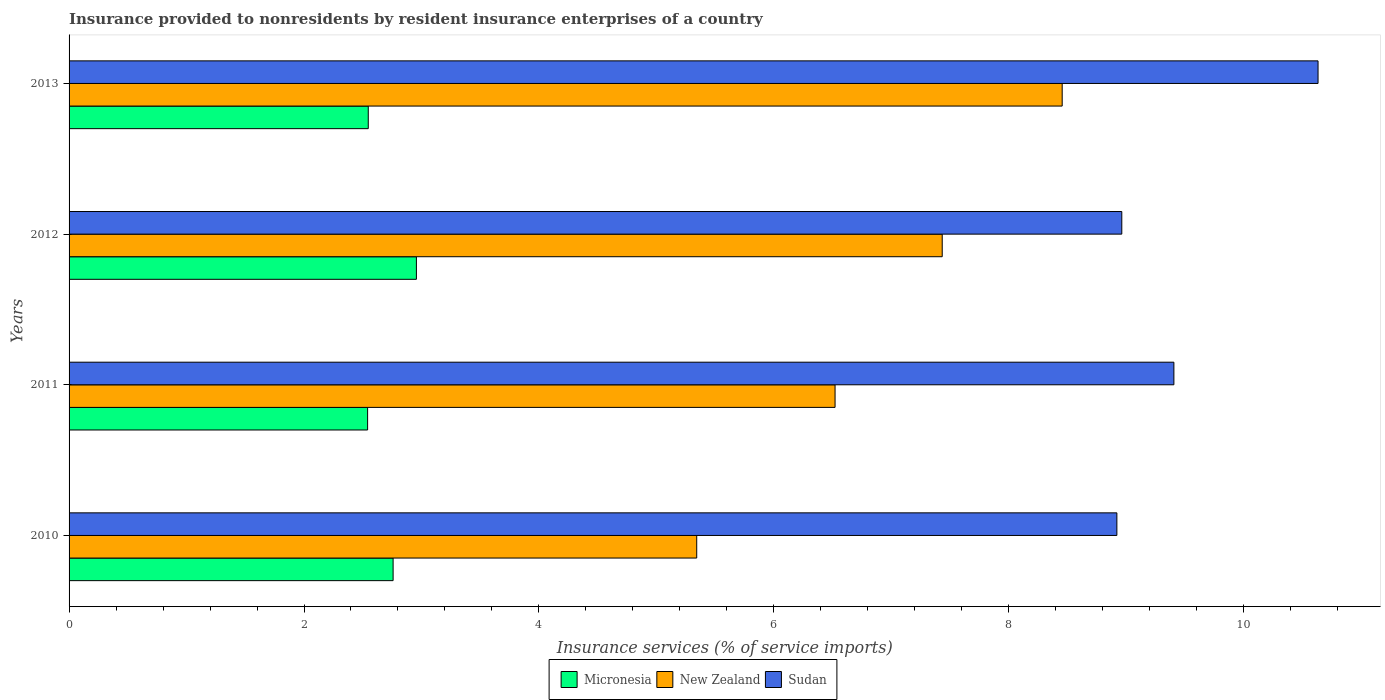How many groups of bars are there?
Provide a short and direct response. 4. Are the number of bars on each tick of the Y-axis equal?
Provide a short and direct response. Yes. How many bars are there on the 2nd tick from the top?
Make the answer very short. 3. How many bars are there on the 2nd tick from the bottom?
Provide a succinct answer. 3. What is the label of the 2nd group of bars from the top?
Offer a very short reply. 2012. What is the insurance provided to nonresidents in Micronesia in 2011?
Make the answer very short. 2.54. Across all years, what is the maximum insurance provided to nonresidents in Micronesia?
Provide a succinct answer. 2.96. Across all years, what is the minimum insurance provided to nonresidents in New Zealand?
Provide a succinct answer. 5.34. What is the total insurance provided to nonresidents in Sudan in the graph?
Ensure brevity in your answer.  37.92. What is the difference between the insurance provided to nonresidents in Sudan in 2011 and that in 2012?
Give a very brief answer. 0.44. What is the difference between the insurance provided to nonresidents in New Zealand in 2010 and the insurance provided to nonresidents in Micronesia in 2011?
Provide a short and direct response. 2.8. What is the average insurance provided to nonresidents in Sudan per year?
Offer a very short reply. 9.48. In the year 2012, what is the difference between the insurance provided to nonresidents in Micronesia and insurance provided to nonresidents in New Zealand?
Offer a terse response. -4.48. What is the ratio of the insurance provided to nonresidents in Sudan in 2012 to that in 2013?
Provide a succinct answer. 0.84. What is the difference between the highest and the second highest insurance provided to nonresidents in New Zealand?
Offer a very short reply. 1.02. What is the difference between the highest and the lowest insurance provided to nonresidents in New Zealand?
Offer a very short reply. 3.11. In how many years, is the insurance provided to nonresidents in New Zealand greater than the average insurance provided to nonresidents in New Zealand taken over all years?
Provide a short and direct response. 2. Is the sum of the insurance provided to nonresidents in New Zealand in 2010 and 2012 greater than the maximum insurance provided to nonresidents in Sudan across all years?
Give a very brief answer. Yes. What does the 3rd bar from the top in 2011 represents?
Keep it short and to the point. Micronesia. What does the 1st bar from the bottom in 2010 represents?
Your answer should be very brief. Micronesia. How many bars are there?
Offer a terse response. 12. Does the graph contain any zero values?
Make the answer very short. No. What is the title of the graph?
Your response must be concise. Insurance provided to nonresidents by resident insurance enterprises of a country. What is the label or title of the X-axis?
Offer a very short reply. Insurance services (% of service imports). What is the Insurance services (% of service imports) in Micronesia in 2010?
Give a very brief answer. 2.76. What is the Insurance services (% of service imports) of New Zealand in 2010?
Ensure brevity in your answer.  5.34. What is the Insurance services (% of service imports) in Sudan in 2010?
Keep it short and to the point. 8.92. What is the Insurance services (% of service imports) of Micronesia in 2011?
Provide a short and direct response. 2.54. What is the Insurance services (% of service imports) of New Zealand in 2011?
Offer a very short reply. 6.52. What is the Insurance services (% of service imports) in Sudan in 2011?
Provide a short and direct response. 9.41. What is the Insurance services (% of service imports) of Micronesia in 2012?
Your answer should be very brief. 2.96. What is the Insurance services (% of service imports) in New Zealand in 2012?
Ensure brevity in your answer.  7.43. What is the Insurance services (% of service imports) in Sudan in 2012?
Ensure brevity in your answer.  8.96. What is the Insurance services (% of service imports) in Micronesia in 2013?
Your answer should be very brief. 2.55. What is the Insurance services (% of service imports) of New Zealand in 2013?
Ensure brevity in your answer.  8.45. What is the Insurance services (% of service imports) of Sudan in 2013?
Keep it short and to the point. 10.63. Across all years, what is the maximum Insurance services (% of service imports) of Micronesia?
Your response must be concise. 2.96. Across all years, what is the maximum Insurance services (% of service imports) in New Zealand?
Keep it short and to the point. 8.45. Across all years, what is the maximum Insurance services (% of service imports) in Sudan?
Ensure brevity in your answer.  10.63. Across all years, what is the minimum Insurance services (% of service imports) of Micronesia?
Your answer should be very brief. 2.54. Across all years, what is the minimum Insurance services (% of service imports) in New Zealand?
Your answer should be compact. 5.34. Across all years, what is the minimum Insurance services (% of service imports) of Sudan?
Offer a very short reply. 8.92. What is the total Insurance services (% of service imports) in Micronesia in the graph?
Your answer should be compact. 10.8. What is the total Insurance services (% of service imports) in New Zealand in the graph?
Your response must be concise. 27.75. What is the total Insurance services (% of service imports) in Sudan in the graph?
Your answer should be very brief. 37.92. What is the difference between the Insurance services (% of service imports) in Micronesia in 2010 and that in 2011?
Your answer should be compact. 0.22. What is the difference between the Insurance services (% of service imports) in New Zealand in 2010 and that in 2011?
Your answer should be very brief. -1.18. What is the difference between the Insurance services (% of service imports) in Sudan in 2010 and that in 2011?
Give a very brief answer. -0.49. What is the difference between the Insurance services (% of service imports) of Micronesia in 2010 and that in 2012?
Make the answer very short. -0.2. What is the difference between the Insurance services (% of service imports) of New Zealand in 2010 and that in 2012?
Provide a short and direct response. -2.09. What is the difference between the Insurance services (% of service imports) in Sudan in 2010 and that in 2012?
Provide a succinct answer. -0.04. What is the difference between the Insurance services (% of service imports) in Micronesia in 2010 and that in 2013?
Provide a succinct answer. 0.21. What is the difference between the Insurance services (% of service imports) of New Zealand in 2010 and that in 2013?
Give a very brief answer. -3.11. What is the difference between the Insurance services (% of service imports) of Sudan in 2010 and that in 2013?
Give a very brief answer. -1.71. What is the difference between the Insurance services (% of service imports) of Micronesia in 2011 and that in 2012?
Provide a short and direct response. -0.42. What is the difference between the Insurance services (% of service imports) in New Zealand in 2011 and that in 2012?
Give a very brief answer. -0.91. What is the difference between the Insurance services (% of service imports) in Sudan in 2011 and that in 2012?
Your response must be concise. 0.44. What is the difference between the Insurance services (% of service imports) of Micronesia in 2011 and that in 2013?
Give a very brief answer. -0.01. What is the difference between the Insurance services (% of service imports) of New Zealand in 2011 and that in 2013?
Your response must be concise. -1.93. What is the difference between the Insurance services (% of service imports) in Sudan in 2011 and that in 2013?
Give a very brief answer. -1.23. What is the difference between the Insurance services (% of service imports) in Micronesia in 2012 and that in 2013?
Offer a very short reply. 0.41. What is the difference between the Insurance services (% of service imports) of New Zealand in 2012 and that in 2013?
Offer a terse response. -1.02. What is the difference between the Insurance services (% of service imports) in Sudan in 2012 and that in 2013?
Make the answer very short. -1.67. What is the difference between the Insurance services (% of service imports) of Micronesia in 2010 and the Insurance services (% of service imports) of New Zealand in 2011?
Provide a short and direct response. -3.76. What is the difference between the Insurance services (% of service imports) in Micronesia in 2010 and the Insurance services (% of service imports) in Sudan in 2011?
Make the answer very short. -6.65. What is the difference between the Insurance services (% of service imports) of New Zealand in 2010 and the Insurance services (% of service imports) of Sudan in 2011?
Offer a terse response. -4.06. What is the difference between the Insurance services (% of service imports) in Micronesia in 2010 and the Insurance services (% of service imports) in New Zealand in 2012?
Your answer should be compact. -4.67. What is the difference between the Insurance services (% of service imports) in Micronesia in 2010 and the Insurance services (% of service imports) in Sudan in 2012?
Keep it short and to the point. -6.2. What is the difference between the Insurance services (% of service imports) in New Zealand in 2010 and the Insurance services (% of service imports) in Sudan in 2012?
Your answer should be very brief. -3.62. What is the difference between the Insurance services (% of service imports) of Micronesia in 2010 and the Insurance services (% of service imports) of New Zealand in 2013?
Offer a terse response. -5.7. What is the difference between the Insurance services (% of service imports) of Micronesia in 2010 and the Insurance services (% of service imports) of Sudan in 2013?
Keep it short and to the point. -7.87. What is the difference between the Insurance services (% of service imports) of New Zealand in 2010 and the Insurance services (% of service imports) of Sudan in 2013?
Provide a short and direct response. -5.29. What is the difference between the Insurance services (% of service imports) of Micronesia in 2011 and the Insurance services (% of service imports) of New Zealand in 2012?
Offer a very short reply. -4.89. What is the difference between the Insurance services (% of service imports) of Micronesia in 2011 and the Insurance services (% of service imports) of Sudan in 2012?
Keep it short and to the point. -6.42. What is the difference between the Insurance services (% of service imports) of New Zealand in 2011 and the Insurance services (% of service imports) of Sudan in 2012?
Ensure brevity in your answer.  -2.44. What is the difference between the Insurance services (% of service imports) of Micronesia in 2011 and the Insurance services (% of service imports) of New Zealand in 2013?
Ensure brevity in your answer.  -5.91. What is the difference between the Insurance services (% of service imports) of Micronesia in 2011 and the Insurance services (% of service imports) of Sudan in 2013?
Provide a succinct answer. -8.09. What is the difference between the Insurance services (% of service imports) in New Zealand in 2011 and the Insurance services (% of service imports) in Sudan in 2013?
Ensure brevity in your answer.  -4.11. What is the difference between the Insurance services (% of service imports) of Micronesia in 2012 and the Insurance services (% of service imports) of New Zealand in 2013?
Give a very brief answer. -5.5. What is the difference between the Insurance services (% of service imports) of Micronesia in 2012 and the Insurance services (% of service imports) of Sudan in 2013?
Ensure brevity in your answer.  -7.68. What is the difference between the Insurance services (% of service imports) in New Zealand in 2012 and the Insurance services (% of service imports) in Sudan in 2013?
Offer a terse response. -3.2. What is the average Insurance services (% of service imports) in Micronesia per year?
Offer a very short reply. 2.7. What is the average Insurance services (% of service imports) of New Zealand per year?
Your answer should be compact. 6.94. What is the average Insurance services (% of service imports) in Sudan per year?
Your response must be concise. 9.48. In the year 2010, what is the difference between the Insurance services (% of service imports) of Micronesia and Insurance services (% of service imports) of New Zealand?
Keep it short and to the point. -2.58. In the year 2010, what is the difference between the Insurance services (% of service imports) in Micronesia and Insurance services (% of service imports) in Sudan?
Keep it short and to the point. -6.16. In the year 2010, what is the difference between the Insurance services (% of service imports) of New Zealand and Insurance services (% of service imports) of Sudan?
Offer a terse response. -3.58. In the year 2011, what is the difference between the Insurance services (% of service imports) of Micronesia and Insurance services (% of service imports) of New Zealand?
Offer a very short reply. -3.98. In the year 2011, what is the difference between the Insurance services (% of service imports) in Micronesia and Insurance services (% of service imports) in Sudan?
Ensure brevity in your answer.  -6.86. In the year 2011, what is the difference between the Insurance services (% of service imports) in New Zealand and Insurance services (% of service imports) in Sudan?
Your response must be concise. -2.88. In the year 2012, what is the difference between the Insurance services (% of service imports) of Micronesia and Insurance services (% of service imports) of New Zealand?
Keep it short and to the point. -4.48. In the year 2012, what is the difference between the Insurance services (% of service imports) of Micronesia and Insurance services (% of service imports) of Sudan?
Provide a short and direct response. -6.01. In the year 2012, what is the difference between the Insurance services (% of service imports) in New Zealand and Insurance services (% of service imports) in Sudan?
Make the answer very short. -1.53. In the year 2013, what is the difference between the Insurance services (% of service imports) of Micronesia and Insurance services (% of service imports) of New Zealand?
Give a very brief answer. -5.91. In the year 2013, what is the difference between the Insurance services (% of service imports) in Micronesia and Insurance services (% of service imports) in Sudan?
Ensure brevity in your answer.  -8.09. In the year 2013, what is the difference between the Insurance services (% of service imports) in New Zealand and Insurance services (% of service imports) in Sudan?
Offer a very short reply. -2.18. What is the ratio of the Insurance services (% of service imports) in Micronesia in 2010 to that in 2011?
Provide a short and direct response. 1.09. What is the ratio of the Insurance services (% of service imports) in New Zealand in 2010 to that in 2011?
Your answer should be very brief. 0.82. What is the ratio of the Insurance services (% of service imports) in Sudan in 2010 to that in 2011?
Make the answer very short. 0.95. What is the ratio of the Insurance services (% of service imports) in Micronesia in 2010 to that in 2012?
Provide a short and direct response. 0.93. What is the ratio of the Insurance services (% of service imports) of New Zealand in 2010 to that in 2012?
Your response must be concise. 0.72. What is the ratio of the Insurance services (% of service imports) of Micronesia in 2010 to that in 2013?
Your answer should be very brief. 1.08. What is the ratio of the Insurance services (% of service imports) in New Zealand in 2010 to that in 2013?
Your answer should be very brief. 0.63. What is the ratio of the Insurance services (% of service imports) of Sudan in 2010 to that in 2013?
Provide a succinct answer. 0.84. What is the ratio of the Insurance services (% of service imports) in Micronesia in 2011 to that in 2012?
Make the answer very short. 0.86. What is the ratio of the Insurance services (% of service imports) in New Zealand in 2011 to that in 2012?
Keep it short and to the point. 0.88. What is the ratio of the Insurance services (% of service imports) of Sudan in 2011 to that in 2012?
Provide a succinct answer. 1.05. What is the ratio of the Insurance services (% of service imports) of New Zealand in 2011 to that in 2013?
Provide a succinct answer. 0.77. What is the ratio of the Insurance services (% of service imports) in Sudan in 2011 to that in 2013?
Provide a short and direct response. 0.88. What is the ratio of the Insurance services (% of service imports) in Micronesia in 2012 to that in 2013?
Your answer should be compact. 1.16. What is the ratio of the Insurance services (% of service imports) in New Zealand in 2012 to that in 2013?
Give a very brief answer. 0.88. What is the ratio of the Insurance services (% of service imports) in Sudan in 2012 to that in 2013?
Provide a short and direct response. 0.84. What is the difference between the highest and the second highest Insurance services (% of service imports) of Micronesia?
Your response must be concise. 0.2. What is the difference between the highest and the second highest Insurance services (% of service imports) of New Zealand?
Your answer should be compact. 1.02. What is the difference between the highest and the second highest Insurance services (% of service imports) in Sudan?
Provide a succinct answer. 1.23. What is the difference between the highest and the lowest Insurance services (% of service imports) of Micronesia?
Your answer should be compact. 0.42. What is the difference between the highest and the lowest Insurance services (% of service imports) of New Zealand?
Offer a very short reply. 3.11. What is the difference between the highest and the lowest Insurance services (% of service imports) in Sudan?
Provide a succinct answer. 1.71. 